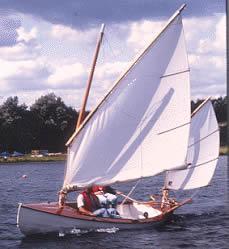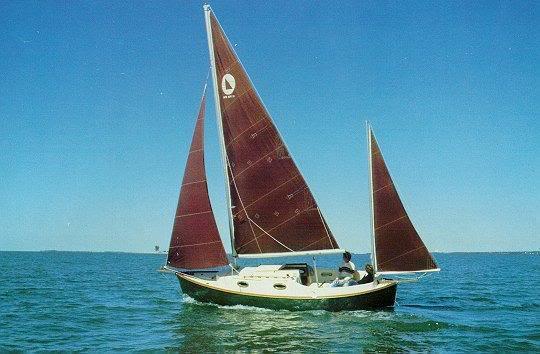The first image is the image on the left, the second image is the image on the right. Assess this claim about the two images: "There appear to be fewer than four people on each boat.". Correct or not? Answer yes or no. Yes. 